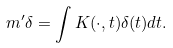<formula> <loc_0><loc_0><loc_500><loc_500>m ^ { \prime } \delta = \int K ( \cdot , t ) \delta ( t ) d t .</formula> 